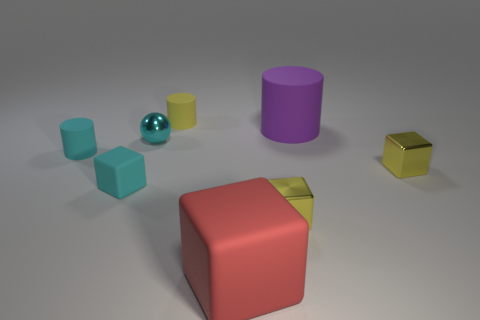Add 2 large yellow matte cylinders. How many objects exist? 10 Subtract all cylinders. How many objects are left? 5 Subtract all green shiny cubes. Subtract all metallic spheres. How many objects are left? 7 Add 3 yellow shiny objects. How many yellow shiny objects are left? 5 Add 1 small brown rubber balls. How many small brown rubber balls exist? 1 Subtract 0 brown blocks. How many objects are left? 8 